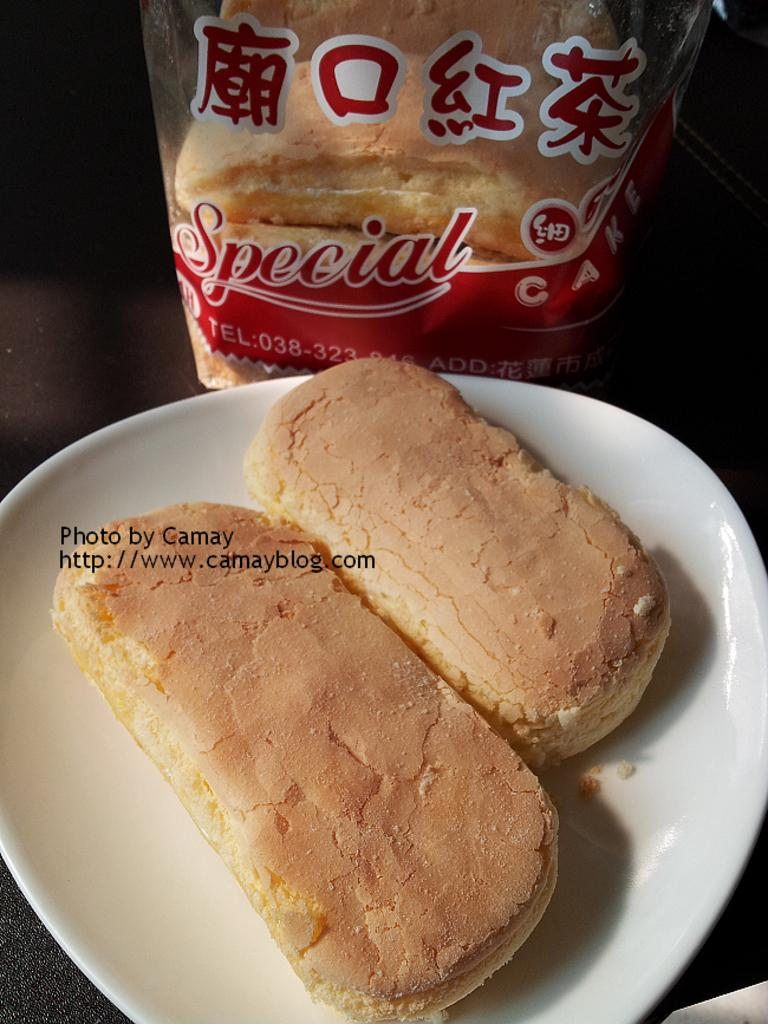What is on the white plate in the image? There is a food item on a white plate in the image. Where is the plate located? The plate is placed on a surface. What else can be seen at the top of the image? There is a packet with text and food at the top of the image. How many legs can be seen supporting the plate in the image? There are no legs visible in the image; the plate is placed on a surface. What type of joke is depicted on the packet in the image? There is no joke present on the packet in the image; it contains text and food. 